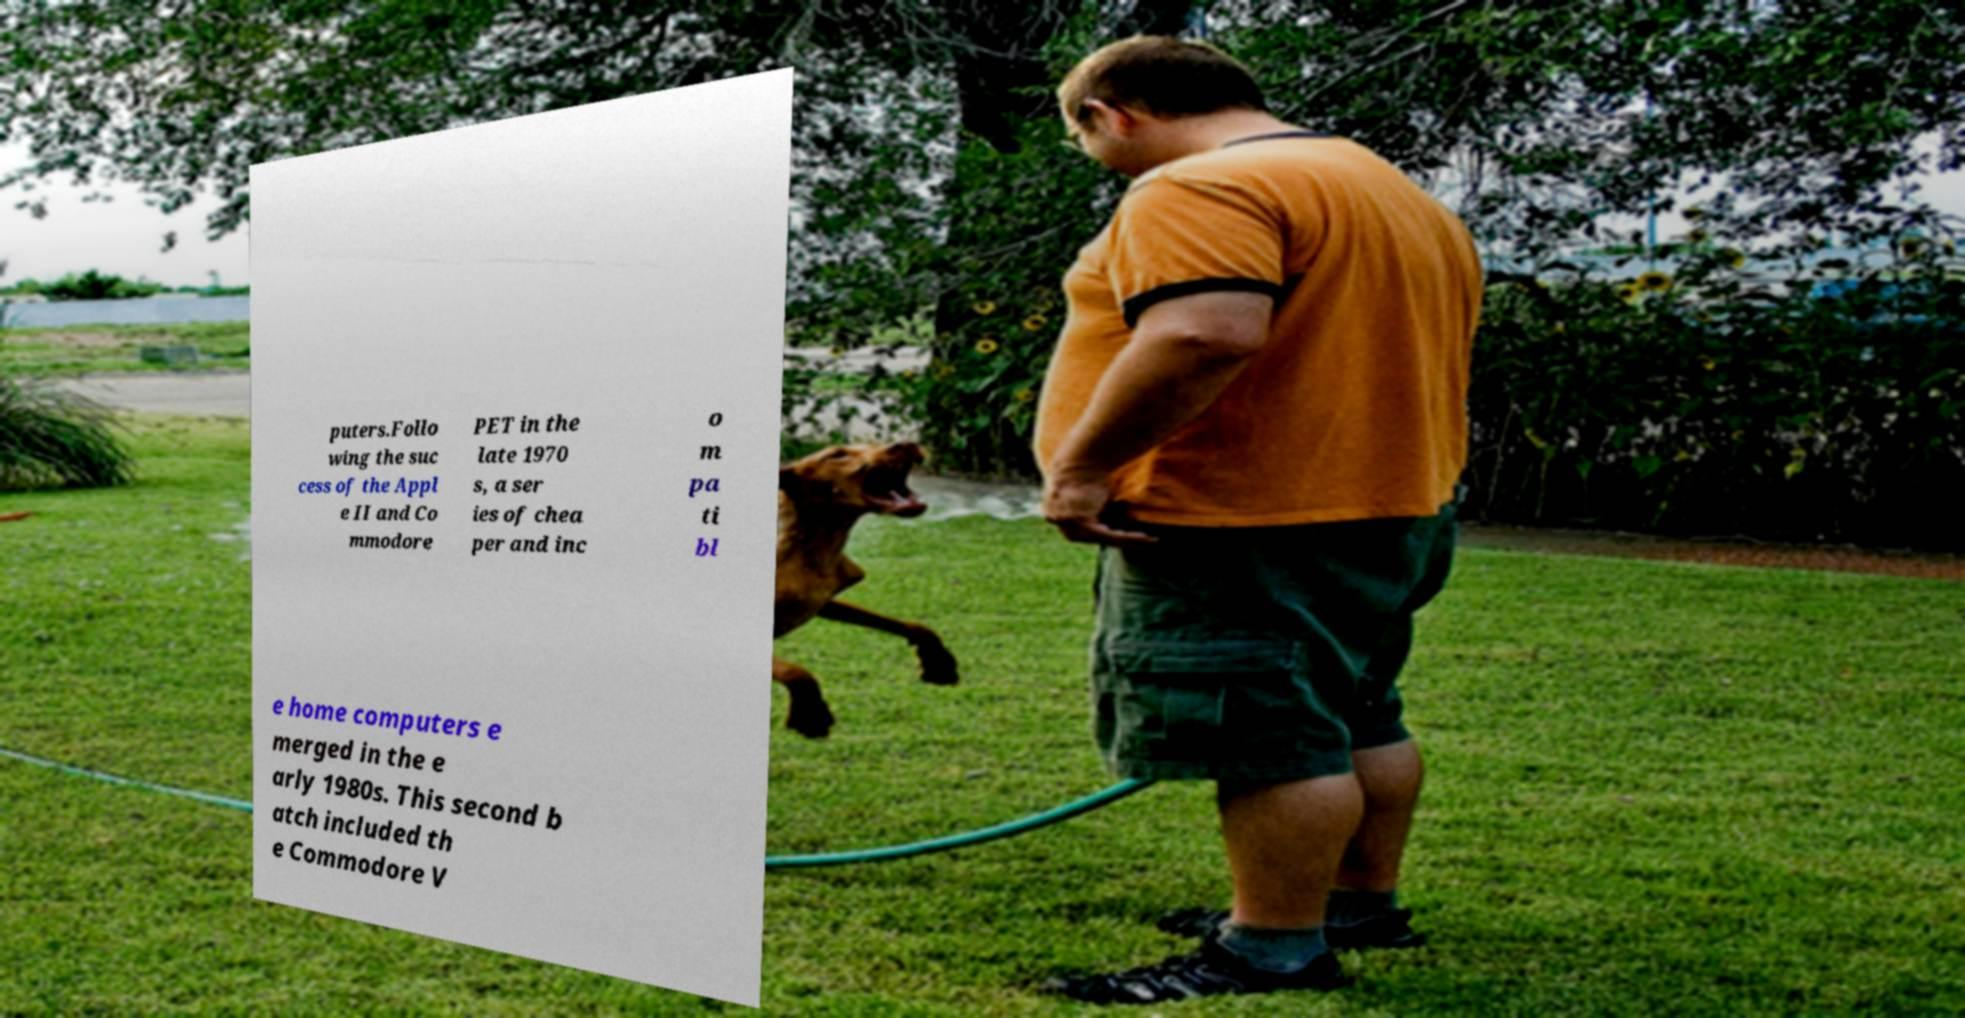There's text embedded in this image that I need extracted. Can you transcribe it verbatim? puters.Follo wing the suc cess of the Appl e II and Co mmodore PET in the late 1970 s, a ser ies of chea per and inc o m pa ti bl e home computers e merged in the e arly 1980s. This second b atch included th e Commodore V 